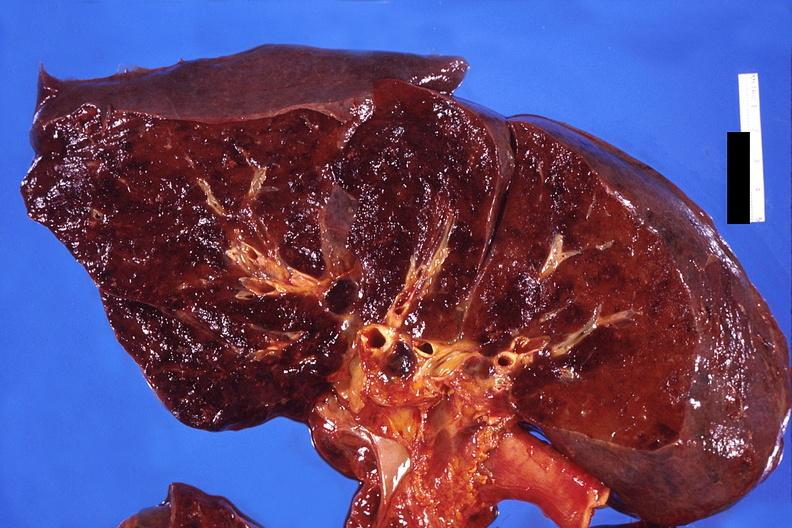where is this?
Answer the question using a single word or phrase. Lung 